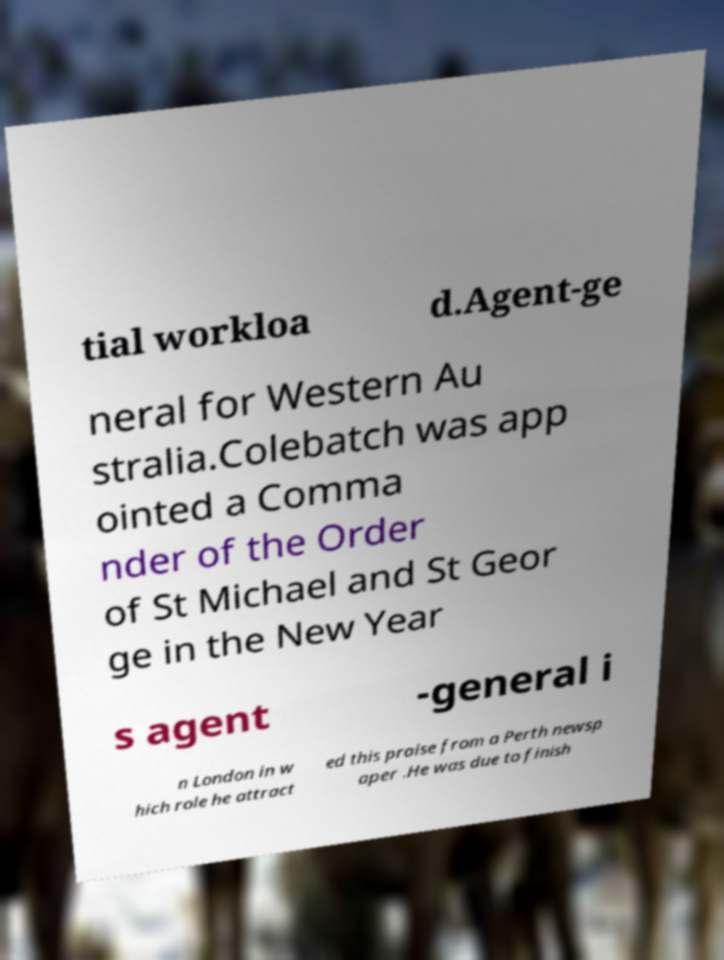Could you extract and type out the text from this image? tial workloa d.Agent-ge neral for Western Au stralia.Colebatch was app ointed a Comma nder of the Order of St Michael and St Geor ge in the New Year s agent -general i n London in w hich role he attract ed this praise from a Perth newsp aper .He was due to finish 